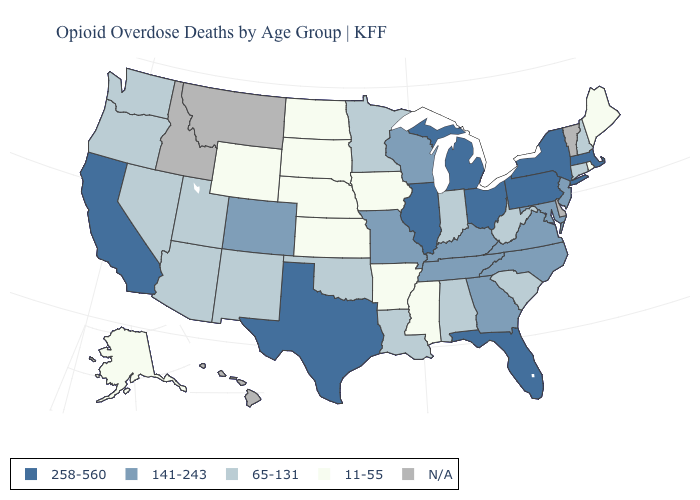What is the lowest value in the West?
Give a very brief answer. 11-55. What is the value of North Dakota?
Be succinct. 11-55. Among the states that border Massachusetts , which have the lowest value?
Concise answer only. Rhode Island. Name the states that have a value in the range 141-243?
Give a very brief answer. Colorado, Georgia, Kentucky, Maryland, Missouri, New Jersey, North Carolina, Tennessee, Virginia, Wisconsin. What is the value of Wisconsin?
Be succinct. 141-243. Name the states that have a value in the range 11-55?
Answer briefly. Alaska, Arkansas, Iowa, Kansas, Maine, Mississippi, Nebraska, North Dakota, Rhode Island, South Dakota, Wyoming. Which states hav the highest value in the West?
Answer briefly. California. Does New York have the highest value in the USA?
Concise answer only. Yes. Among the states that border North Dakota , does Minnesota have the lowest value?
Short answer required. No. What is the lowest value in the South?
Write a very short answer. 11-55. What is the value of Indiana?
Keep it brief. 65-131. What is the lowest value in the Northeast?
Short answer required. 11-55. Does the map have missing data?
Give a very brief answer. Yes. What is the highest value in the South ?
Quick response, please. 258-560. 